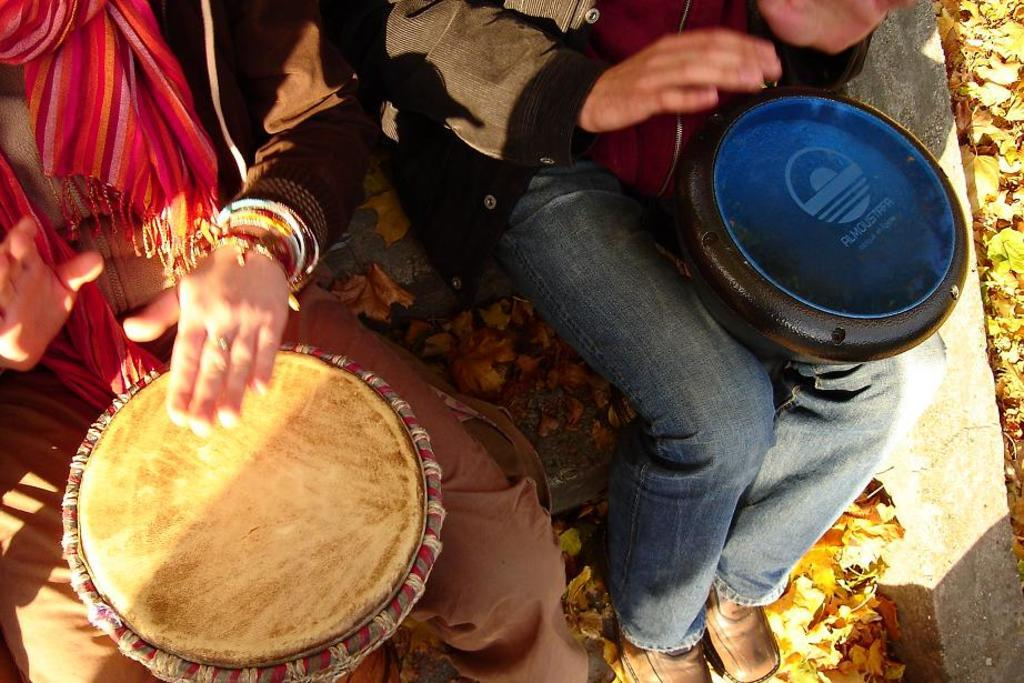What are the persons in the image doing? The persons in the image are sitting. What object can be seen in the image besides the sitting persons? There is a drum present in the image. How is the drum positioned in relation to the sitting persons? The drum is placed in between the laps of the sitting persons. What flavor of jam is spread on the drum in the image? There is no jam present in the image, and the drum is not an object that would typically have jam spread on it. 